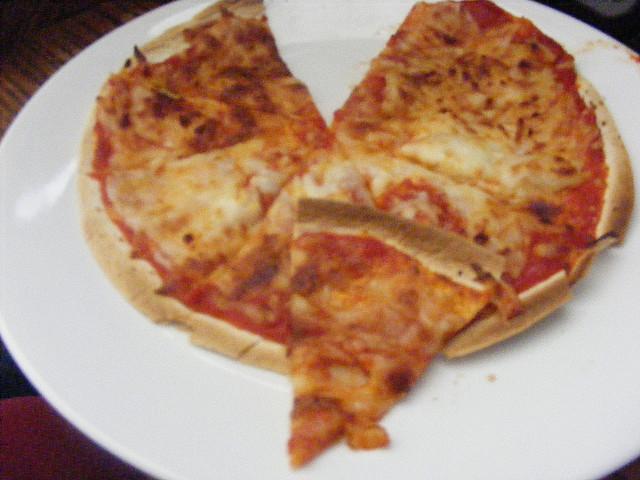Does this pizza look appetizing?
Short answer required. No. Does this contain crushed ingredients?
Short answer required. No. How many slices are moved from the pizza?
Be succinct. 1. Are there vegetables on this plate?
Short answer required. No. Is this deep dish?
Write a very short answer. No. Would a vegetarian eat this?
Give a very brief answer. Yes. Is the food on the plate likely to be served at a children's party?
Keep it brief. Yes. What is on this plate?
Short answer required. Pizza. Where is the white plate?
Quick response, please. Under pizza. Is this a pepperoni pizza?
Write a very short answer. No. Does this pizza have seasoning on top?
Write a very short answer. No. 